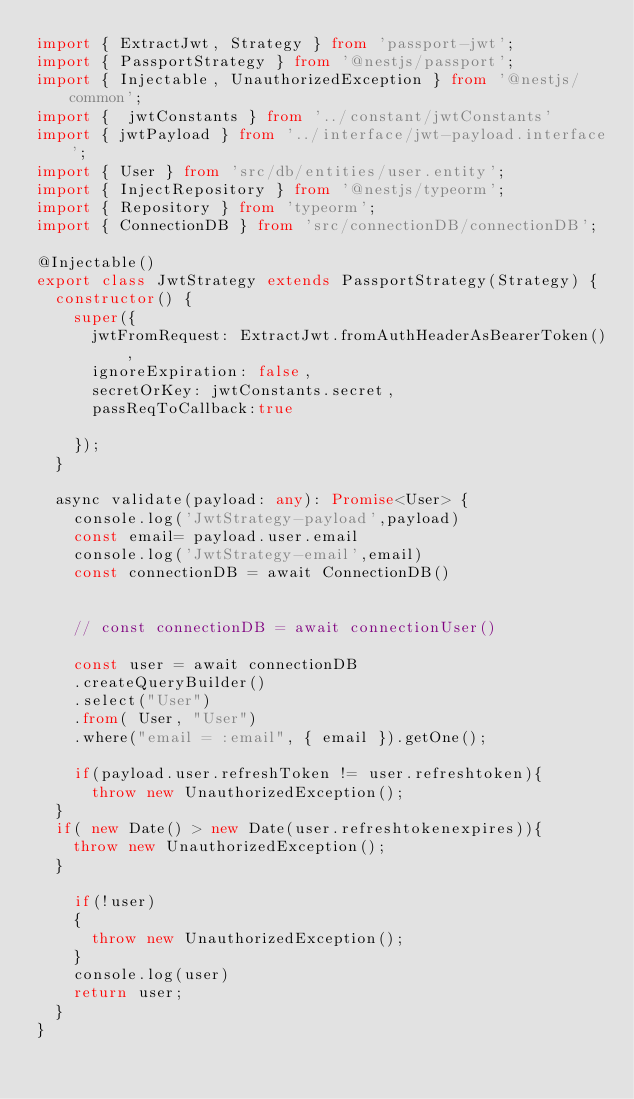Convert code to text. <code><loc_0><loc_0><loc_500><loc_500><_TypeScript_>import { ExtractJwt, Strategy } from 'passport-jwt';
import { PassportStrategy } from '@nestjs/passport';
import { Injectable, UnauthorizedException } from '@nestjs/common';
import {  jwtConstants } from '../constant/jwtConstants'
import { jwtPayload } from '../interface/jwt-payload.interface';
import { User } from 'src/db/entities/user.entity';
import { InjectRepository } from '@nestjs/typeorm';
import { Repository } from 'typeorm';
import { ConnectionDB } from 'src/connectionDB/connectionDB';

@Injectable()
export class JwtStrategy extends PassportStrategy(Strategy) {
  constructor() {
    super({
      jwtFromRequest: ExtractJwt.fromAuthHeaderAsBearerToken(),
      ignoreExpiration: false,
      secretOrKey: jwtConstants.secret,
      passReqToCallback:true

    });
  }

  async validate(payload: any): Promise<User> {
    console.log('JwtStrategy-payload',payload)
    const email= payload.user.email
    console.log('JwtStrategy-email',email)
    const connectionDB = await ConnectionDB()

    
    // const connectionDB = await connectionUser()

    const user = await connectionDB
    .createQueryBuilder() 
    .select("User")
    .from( User, "User")
    .where("email = :email", { email }).getOne();
    
    if(payload.user.refreshToken != user.refreshtoken){
      throw new UnauthorizedException();
  }
  if( new Date() > new Date(user.refreshtokenexpires)){
    throw new UnauthorizedException();
  }

    if(!user)
    {
      throw new UnauthorizedException();
    }
    console.log(user)
    return user;
  }
}</code> 